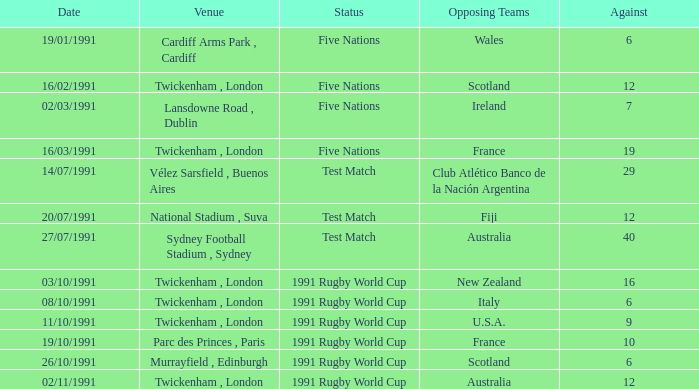Parse the table in full. {'header': ['Date', 'Venue', 'Status', 'Opposing Teams', 'Against'], 'rows': [['19/01/1991', 'Cardiff Arms Park , Cardiff', 'Five Nations', 'Wales', '6'], ['16/02/1991', 'Twickenham , London', 'Five Nations', 'Scotland', '12'], ['02/03/1991', 'Lansdowne Road , Dublin', 'Five Nations', 'Ireland', '7'], ['16/03/1991', 'Twickenham , London', 'Five Nations', 'France', '19'], ['14/07/1991', 'Vélez Sarsfield , Buenos Aires', 'Test Match', 'Club Atlético Banco de la Nación Argentina', '29'], ['20/07/1991', 'National Stadium , Suva', 'Test Match', 'Fiji', '12'], ['27/07/1991', 'Sydney Football Stadium , Sydney', 'Test Match', 'Australia', '40'], ['03/10/1991', 'Twickenham , London', '1991 Rugby World Cup', 'New Zealand', '16'], ['08/10/1991', 'Twickenham , London', '1991 Rugby World Cup', 'Italy', '6'], ['11/10/1991', 'Twickenham , London', '1991 Rugby World Cup', 'U.S.A.', '9'], ['19/10/1991', 'Parc des Princes , Paris', '1991 Rugby World Cup', 'France', '10'], ['26/10/1991', 'Murrayfield , Edinburgh', '1991 Rugby World Cup', 'Scotland', '6'], ['02/11/1991', 'Twickenham , London', '1991 Rugby World Cup', 'Australia', '12']]} What is Date, when Opposing Teams is "Australia", and when Venue is "Twickenham , London"? 02/11/1991. 